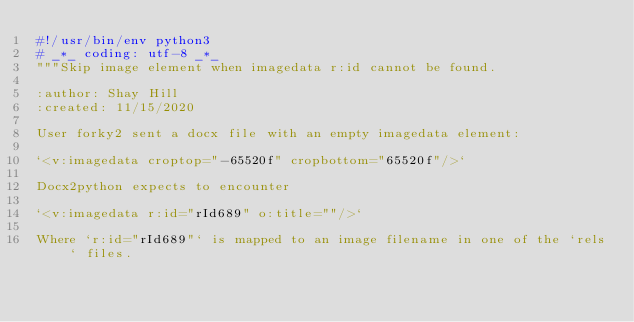Convert code to text. <code><loc_0><loc_0><loc_500><loc_500><_Python_>#!/usr/bin/env python3
# _*_ coding: utf-8 _*_
"""Skip image element when imagedata r:id cannot be found.

:author: Shay Hill
:created: 11/15/2020

User forky2 sent a docx file with an empty imagedata element:

`<v:imagedata croptop="-65520f" cropbottom="65520f"/>`

Docx2python expects to encounter

`<v:imagedata r:id="rId689" o:title=""/>`

Where `r:id="rId689"` is mapped to an image filename in one of the `rels` files.
</code> 